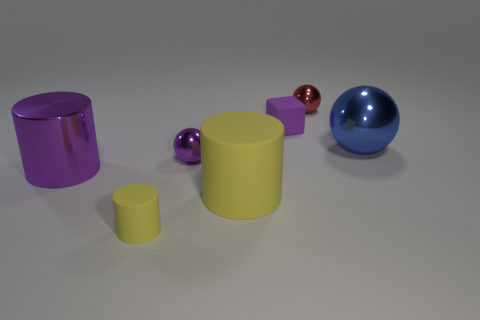How many matte objects are the same size as the purple cylinder?
Keep it short and to the point. 1. The cylinder that is the same color as the large rubber thing is what size?
Your response must be concise. Small. Are there any things of the same color as the large metal sphere?
Provide a succinct answer. No. What color is the rubber thing that is the same size as the blue metal thing?
Ensure brevity in your answer.  Yellow. There is a big sphere; is its color the same as the tiny sphere in front of the blue shiny thing?
Provide a short and direct response. No. What color is the big shiny cylinder?
Provide a short and direct response. Purple. What material is the sphere on the left side of the red ball?
Ensure brevity in your answer.  Metal. What is the size of the blue thing that is the same shape as the small red shiny thing?
Keep it short and to the point. Large. Is the number of large yellow rubber cylinders that are to the left of the tiny purple shiny sphere less than the number of big gray objects?
Provide a short and direct response. No. Is there a tiny red thing?
Ensure brevity in your answer.  Yes. 